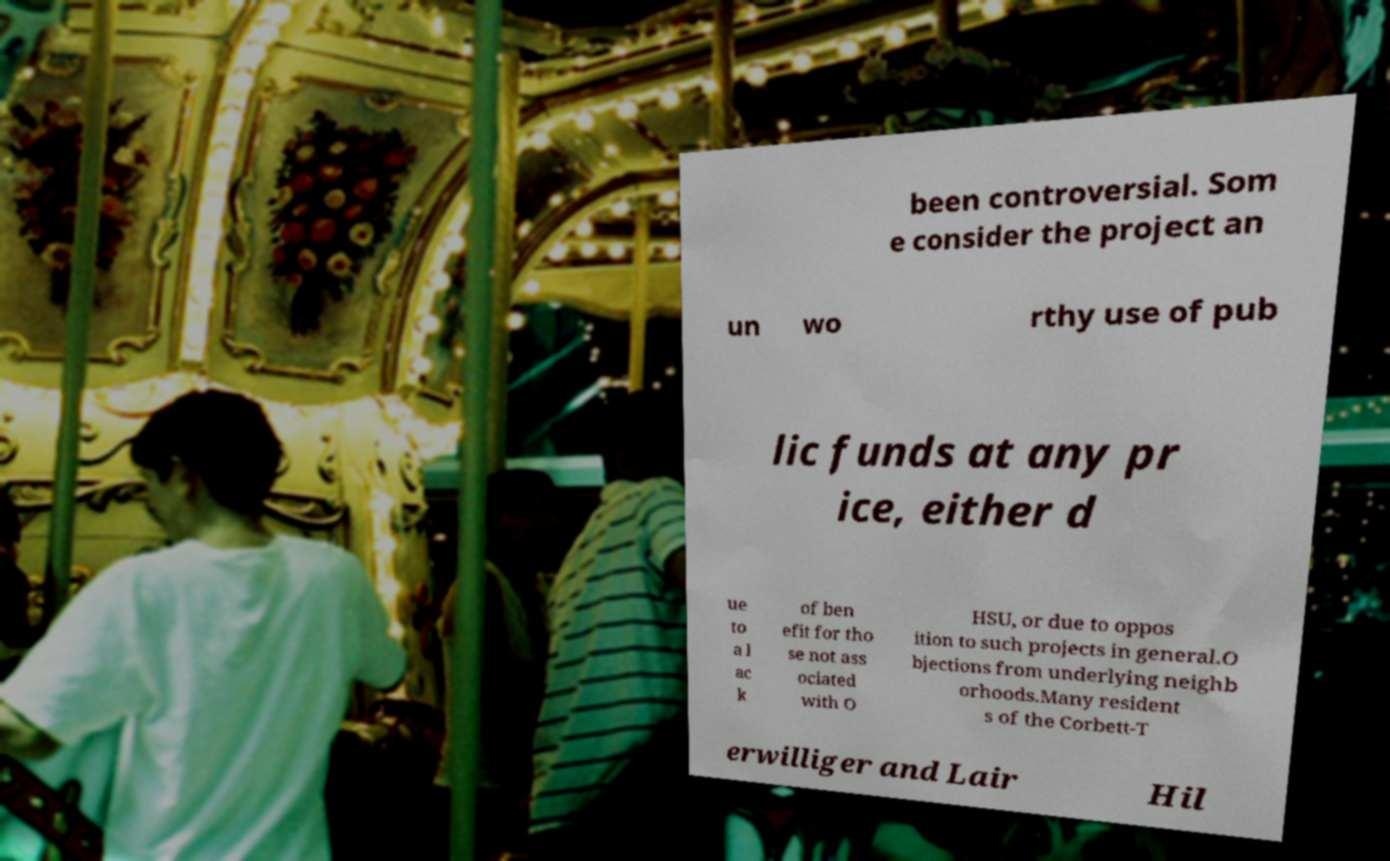For documentation purposes, I need the text within this image transcribed. Could you provide that? been controversial. Som e consider the project an un wo rthy use of pub lic funds at any pr ice, either d ue to a l ac k of ben efit for tho se not ass ociated with O HSU, or due to oppos ition to such projects in general.O bjections from underlying neighb orhoods.Many resident s of the Corbett-T erwilliger and Lair Hil 